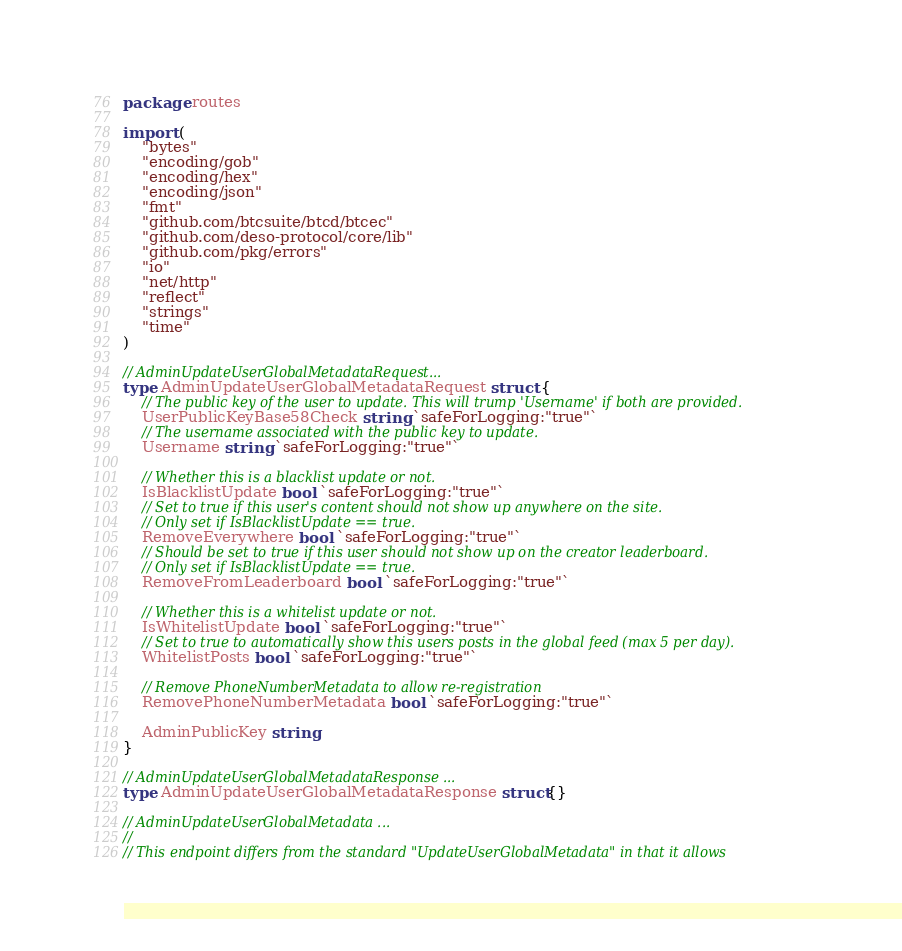Convert code to text. <code><loc_0><loc_0><loc_500><loc_500><_Go_>package routes

import (
	"bytes"
	"encoding/gob"
	"encoding/hex"
	"encoding/json"
	"fmt"
	"github.com/btcsuite/btcd/btcec"
	"github.com/deso-protocol/core/lib"
	"github.com/pkg/errors"
	"io"
	"net/http"
	"reflect"
	"strings"
	"time"
)

// AdminUpdateUserGlobalMetadataRequest...
type AdminUpdateUserGlobalMetadataRequest struct {
	// The public key of the user to update. This will trump 'Username' if both are provided.
	UserPublicKeyBase58Check string `safeForLogging:"true"`
	// The username associated with the public key to update.
	Username string `safeForLogging:"true"`

	// Whether this is a blacklist update or not.
	IsBlacklistUpdate bool `safeForLogging:"true"`
	// Set to true if this user's content should not show up anywhere on the site.
	// Only set if IsBlacklistUpdate == true.
	RemoveEverywhere bool `safeForLogging:"true"`
	// Should be set to true if this user should not show up on the creator leaderboard.
	// Only set if IsBlacklistUpdate == true.
	RemoveFromLeaderboard bool `safeForLogging:"true"`

	// Whether this is a whitelist update or not.
	IsWhitelistUpdate bool `safeForLogging:"true"`
	// Set to true to automatically show this users posts in the global feed (max 5 per day).
	WhitelistPosts bool `safeForLogging:"true"`

	// Remove PhoneNumberMetadata to allow re-registration
	RemovePhoneNumberMetadata bool `safeForLogging:"true"`

	AdminPublicKey string
}

// AdminUpdateUserGlobalMetadataResponse ...
type AdminUpdateUserGlobalMetadataResponse struct{}

// AdminUpdateUserGlobalMetadata ...
//
// This endpoint differs from the standard "UpdateUserGlobalMetadata" in that it allows</code> 